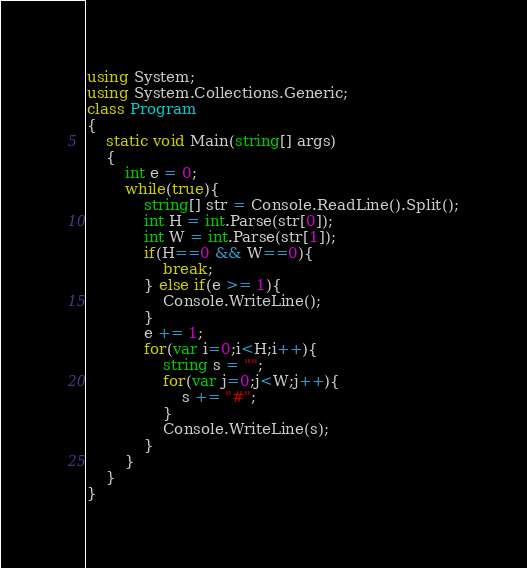<code> <loc_0><loc_0><loc_500><loc_500><_C#_>using System;
using System.Collections.Generic;
class Program
{
	static void Main(string[] args)
	{
		int e = 0;
		while(true){
			string[] str = Console.ReadLine().Split();
			int H = int.Parse(str[0]);
			int W = int.Parse(str[1]);
			if(H==0 && W==0){
				break;
			} else if(e >= 1){
				Console.WriteLine();
			}
			e += 1;
			for(var i=0;i<H;i++){
				string s = "";
				for(var j=0;j<W;j++){
					s += "#";
				}
				Console.WriteLine(s);
			}
		}
	}
}
</code> 